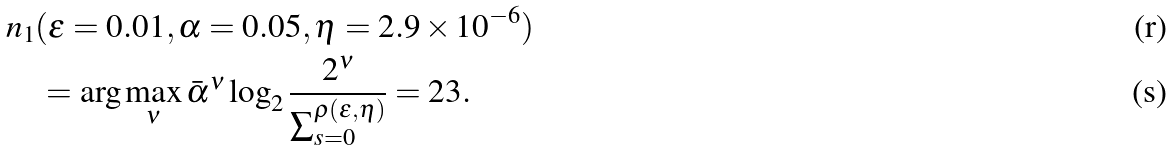Convert formula to latex. <formula><loc_0><loc_0><loc_500><loc_500>& n _ { 1 } ( \varepsilon = 0 . 0 1 , \alpha = 0 . 0 5 , \eta = 2 . 9 \times 1 0 ^ { - 6 } ) \\ & \quad = \arg \max _ { \nu } \bar { \alpha } ^ { \nu } \log _ { 2 } \frac { 2 ^ { \nu } } { \sum _ { s = 0 } ^ { \rho ( \varepsilon , \eta ) } } = 2 3 .</formula> 